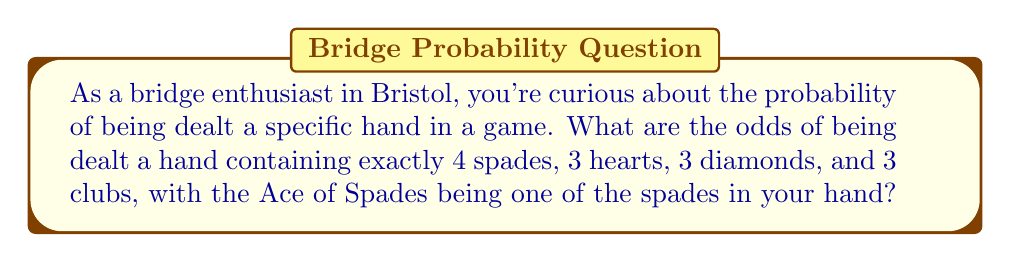Help me with this question. Let's approach this step-by-step:

1) First, we need to calculate the total number of possible bridge hands. This is given by the combination formula:

   $$\binom{52}{13} = \frac{52!}{13!(52-13)!} = 635,013,559,600$$

2) Now, let's break down the probability of getting each suit:

   a) Spades: We need 4 spades, one of which must be the Ace. So we're choosing 3 from the remaining 12 spades:
      $$\binom{12}{3} = 220$$

   b) Hearts: We need 3 hearts from 13:
      $$\binom{13}{3} = 286$$

   c) Diamonds: We need 3 diamonds from 13:
      $$\binom{13}{3} = 286$$

   d) Clubs: We need 3 clubs from 13:
      $$\binom{13}{3} = 286$$

3) The total number of ways to get this specific distribution with the Ace of Spades is:

   $$220 \times 286 \times 286 \times 286 = 5,194,777,760$$

4) The probability is thus:

   $$P = \frac{5,194,777,760}{635,013,559,600} = \frac{1}{122.24} \approx 0.008181$$

5) To express this as odds, we divide 1 by the probability:

   $$\text{Odds} = \frac{1}{0.008181} \approx 122.24 \text{ to } 1$$
Answer: The odds of being dealt a hand with exactly 4 spades (including the Ace of Spades), 3 hearts, 3 diamonds, and 3 clubs are approximately 122.24 to 1. 